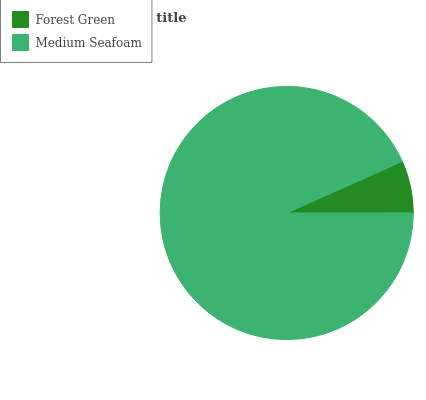Is Forest Green the minimum?
Answer yes or no. Yes. Is Medium Seafoam the maximum?
Answer yes or no. Yes. Is Medium Seafoam the minimum?
Answer yes or no. No. Is Medium Seafoam greater than Forest Green?
Answer yes or no. Yes. Is Forest Green less than Medium Seafoam?
Answer yes or no. Yes. Is Forest Green greater than Medium Seafoam?
Answer yes or no. No. Is Medium Seafoam less than Forest Green?
Answer yes or no. No. Is Medium Seafoam the high median?
Answer yes or no. Yes. Is Forest Green the low median?
Answer yes or no. Yes. Is Forest Green the high median?
Answer yes or no. No. Is Medium Seafoam the low median?
Answer yes or no. No. 